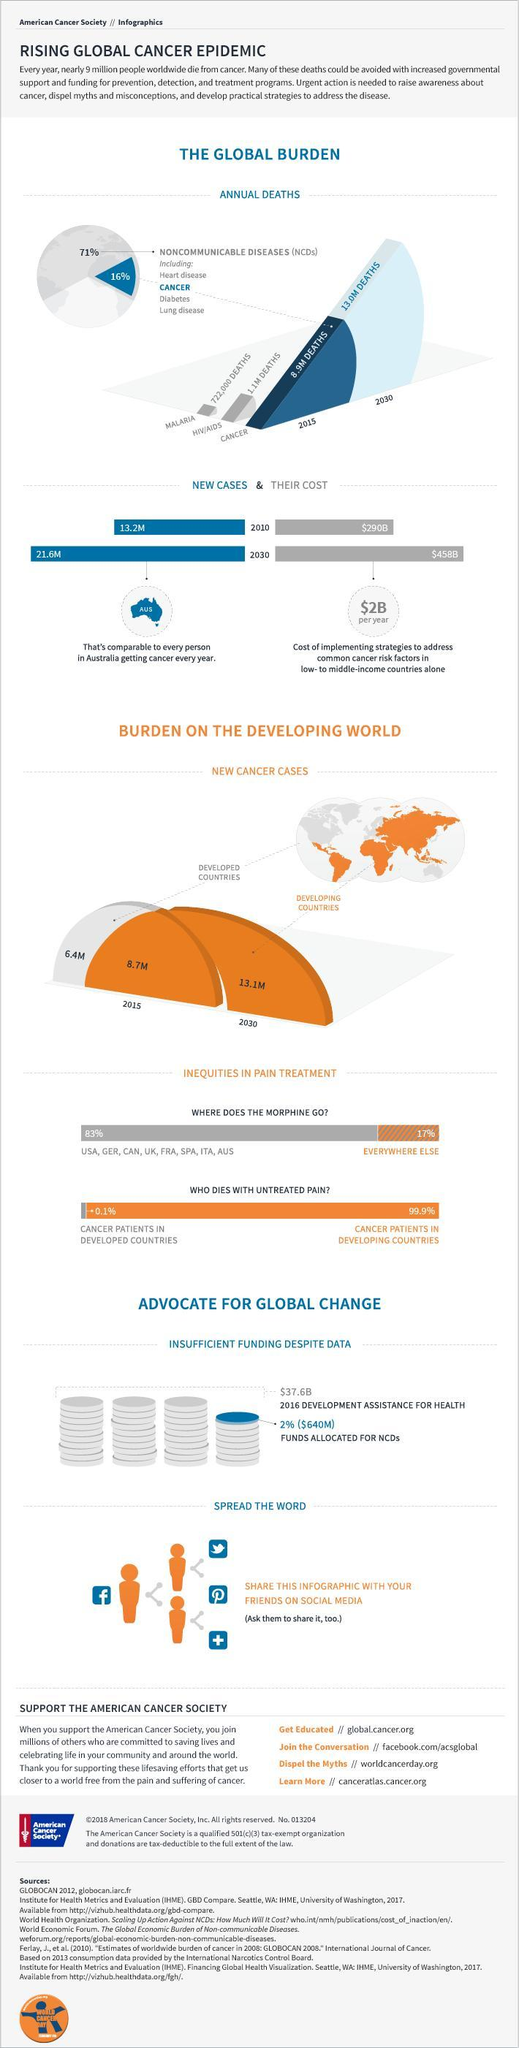How many people died due to HIV/AIDS  globally in 2015?
Answer the question with a short phrase. 1.1M DEATHS What is the number of new cancer cases in developed countries in 2015? 6.4M What is the projected number of new cancer cases in developing countries by 2030? 13.1M What percent of cancer patients in developed countries dies out of untreated pain? 0.1% What is the projected number of cancer deaths by 2030? 13.0M DEATHS How many cancer deaths were reported in 2015? 8.9M DEATHS How many new cancer cases were reported in developing countries in 2015? 8.7M What percent of cancer patients in developing countries dies out of untreated pain? 99.9% 